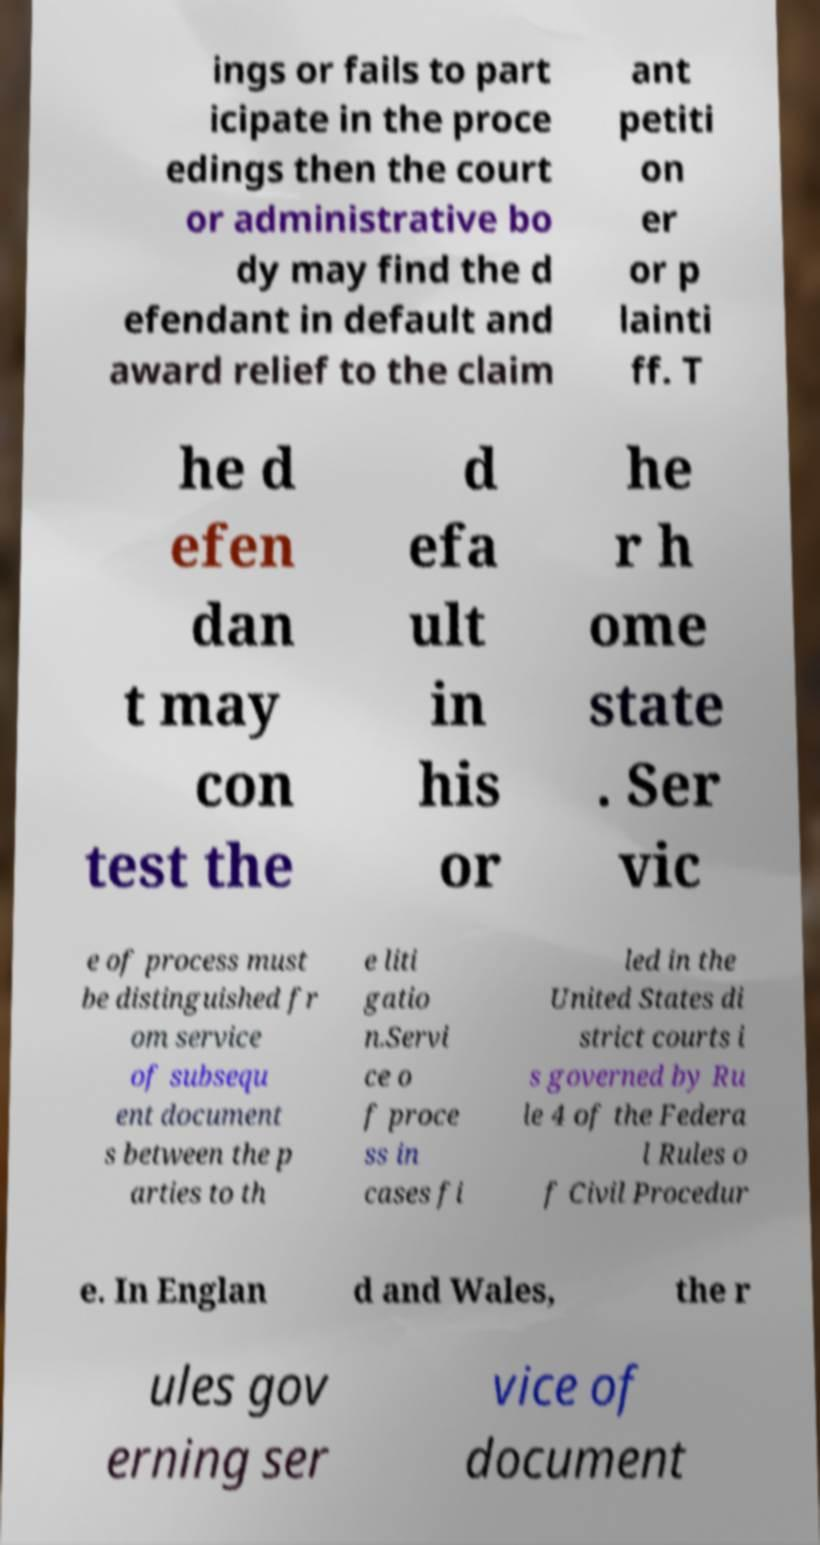For documentation purposes, I need the text within this image transcribed. Could you provide that? ings or fails to part icipate in the proce edings then the court or administrative bo dy may find the d efendant in default and award relief to the claim ant petiti on er or p lainti ff. T he d efen dan t may con test the d efa ult in his or he r h ome state . Ser vic e of process must be distinguished fr om service of subsequ ent document s between the p arties to th e liti gatio n.Servi ce o f proce ss in cases fi led in the United States di strict courts i s governed by Ru le 4 of the Federa l Rules o f Civil Procedur e. In Englan d and Wales, the r ules gov erning ser vice of document 